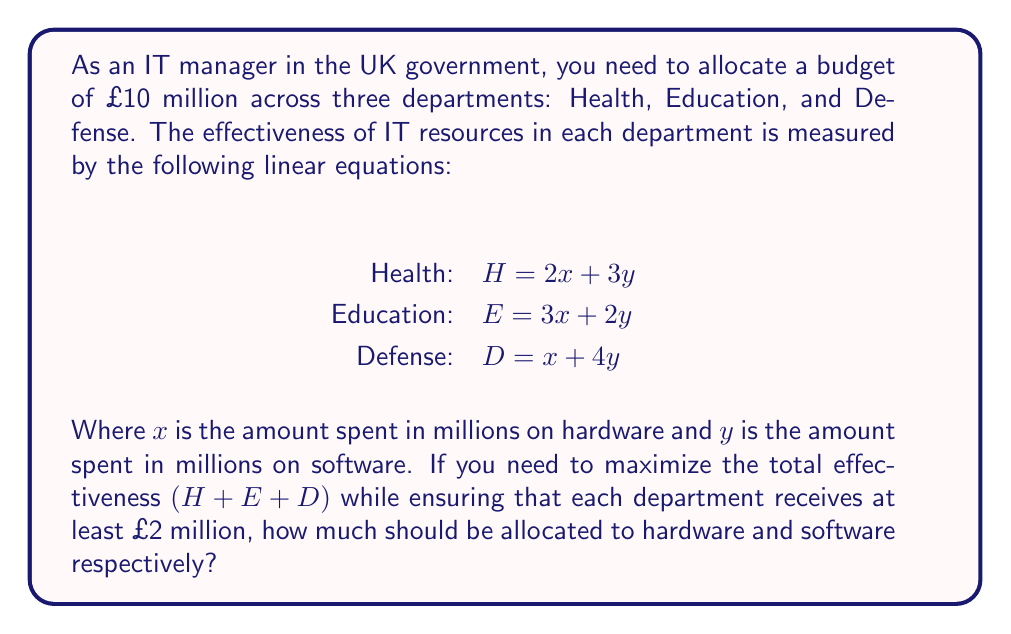Teach me how to tackle this problem. Let's approach this step-by-step:

1) First, we need to set up our objective function. We want to maximize the total effectiveness:

   $\text{Total} = H + E + D = (2x + 3y) + (3x + 2y) + (x + 4y) = 6x + 9y$

2) Now, we have constraints:
   - Total budget: $x + y = 10$ (since $x$ and $y$ are in millions)
   - Each department gets at least £2 million: $x + y \geq 2$ for each department

3) The constraint $x + y \geq 2$ is already satisfied by $x + y = 10$, so we can ignore it.

4) Our problem is now a linear programming problem:

   Maximize: $6x + 9y$
   Subject to: $x + y = 10$
               $x \geq 0$, $y \geq 0$

5) We can solve this graphically or algebraically. Let's use the algebraic method:

   From $x + y = 10$, we can express $y$ in terms of $x$:
   $y = 10 - x$

6) Substituting this into our objective function:

   $6x + 9y = 6x + 9(10 - x) = 6x + 90 - 9x = 90 - 3x$

7) To maximize this, we want $x$ to be as small as possible (since the coefficient of $x$ is negative). However, $x$ can't be negative.

8) Therefore, the optimal solution is $x = 0$ and $y = 10$.

9) This means all £10 million should be spent on software ($y$) and none on hardware ($x$).
Answer: $x = 0$, $y = 10$ 